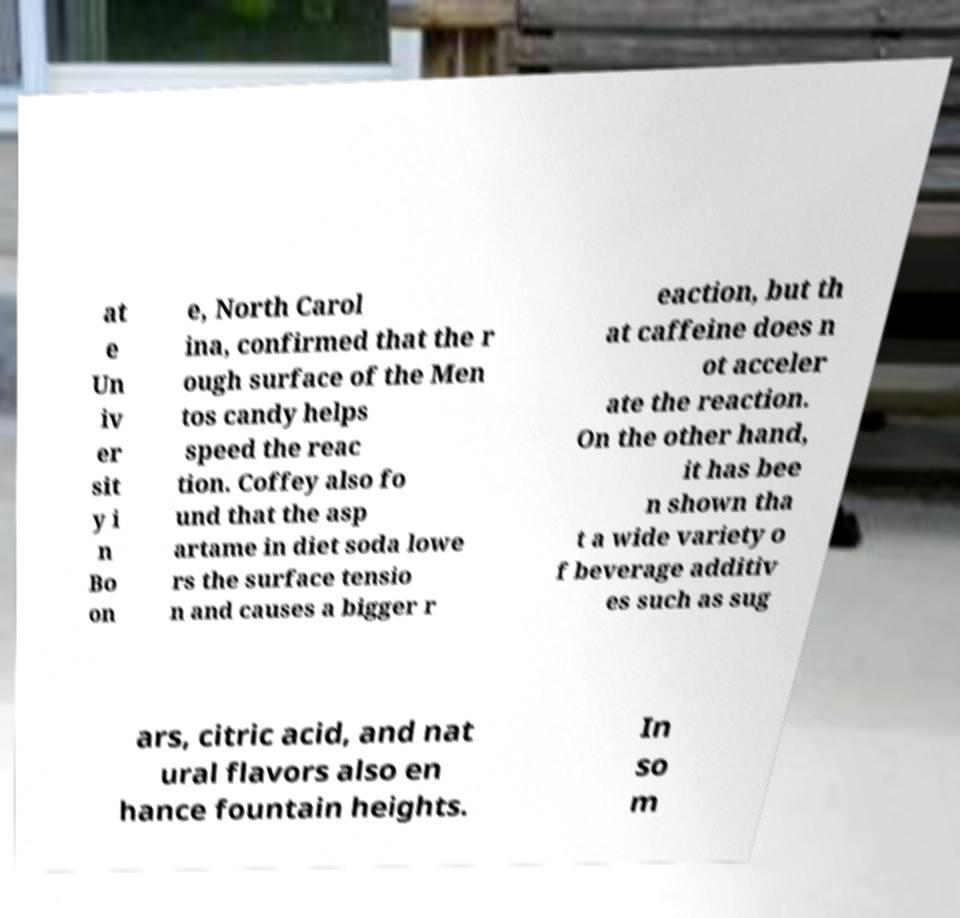Please identify and transcribe the text found in this image. at e Un iv er sit y i n Bo on e, North Carol ina, confirmed that the r ough surface of the Men tos candy helps speed the reac tion. Coffey also fo und that the asp artame in diet soda lowe rs the surface tensio n and causes a bigger r eaction, but th at caffeine does n ot acceler ate the reaction. On the other hand, it has bee n shown tha t a wide variety o f beverage additiv es such as sug ars, citric acid, and nat ural flavors also en hance fountain heights. In so m 